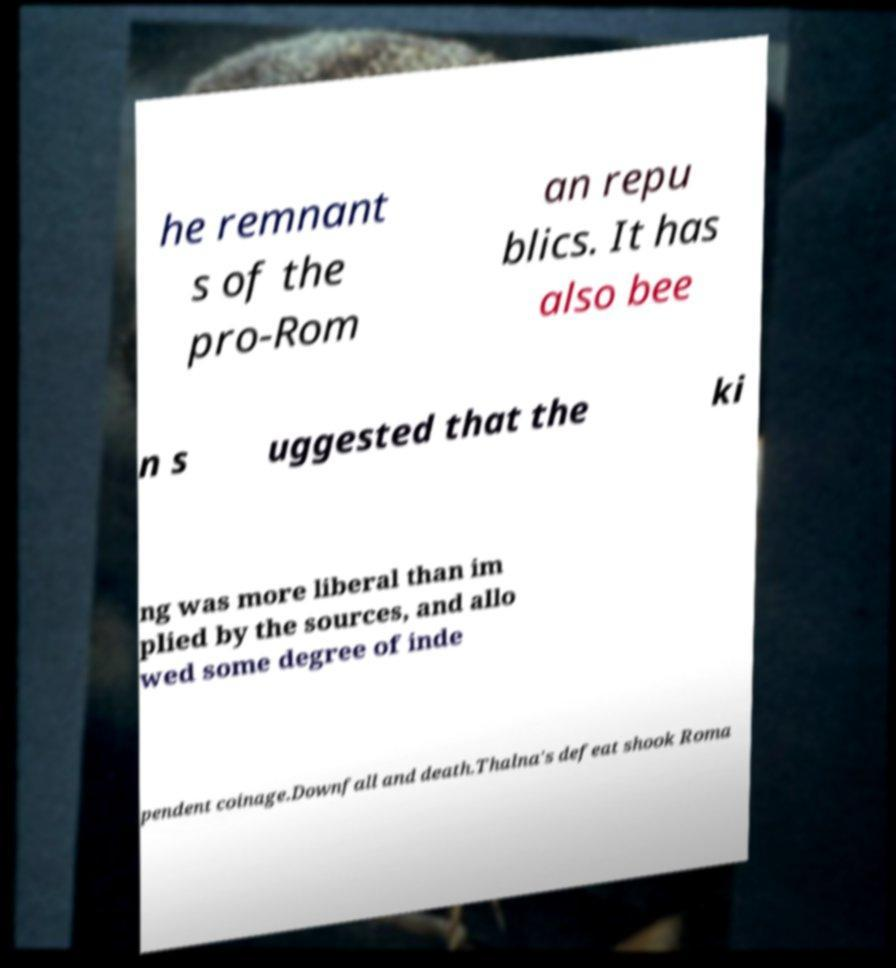What messages or text are displayed in this image? I need them in a readable, typed format. he remnant s of the pro-Rom an repu blics. It has also bee n s uggested that the ki ng was more liberal than im plied by the sources, and allo wed some degree of inde pendent coinage.Downfall and death.Thalna's defeat shook Roma 